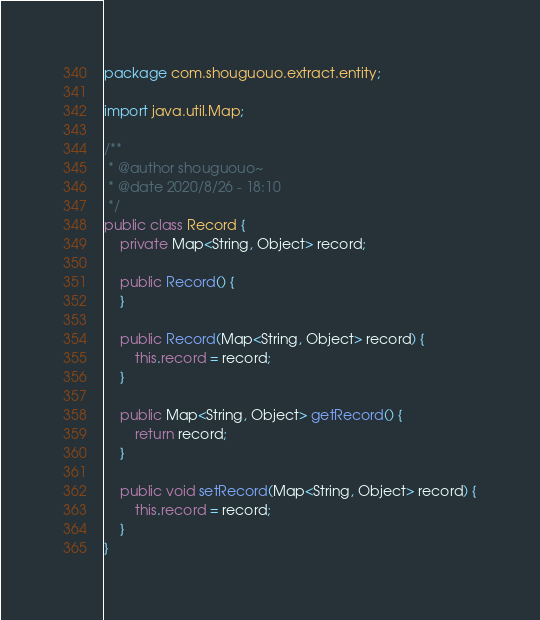Convert code to text. <code><loc_0><loc_0><loc_500><loc_500><_Java_>package com.shouguouo.extract.entity;

import java.util.Map;

/**
 * @author shouguouo~
 * @date 2020/8/26 - 18:10
 */
public class Record {
    private Map<String, Object> record;

    public Record() {
    }

    public Record(Map<String, Object> record) {
        this.record = record;
    }

    public Map<String, Object> getRecord() {
        return record;
    }

    public void setRecord(Map<String, Object> record) {
        this.record = record;
    }
}
</code> 